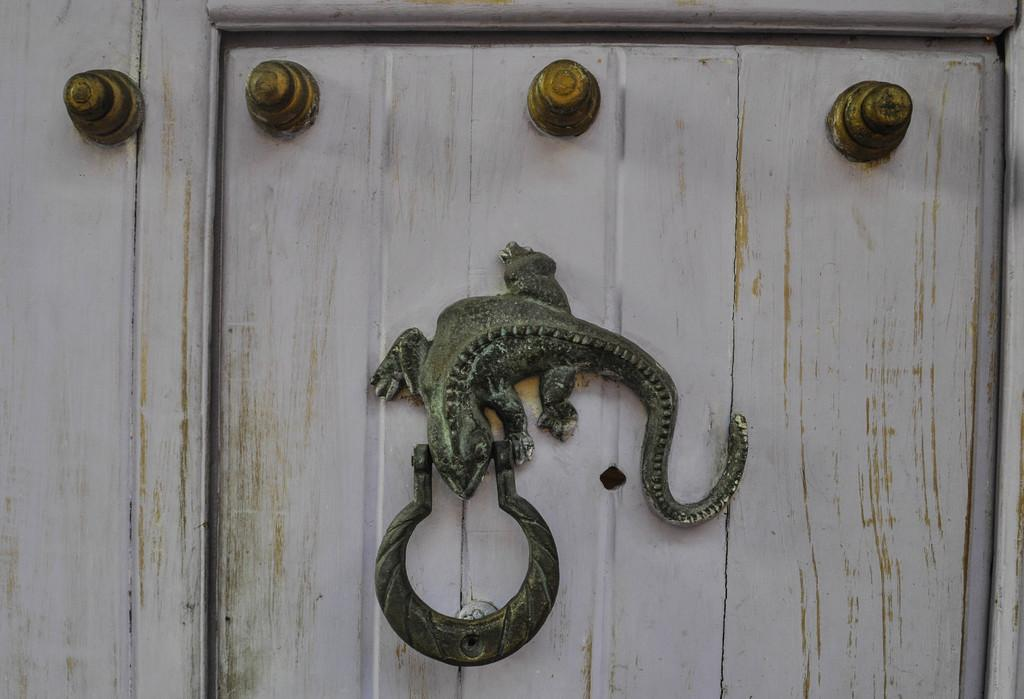What type of door is visible in the image? There is a wooden door in the image. What security features are present on the wooden door? The wooden door has bolts. What is used to hold the wooden door in place? The wooden door has a holder. What additional decorative element can be seen in the image? There is an animal sculpture in the image. What type of sheet is covering the animal sculpture in the image? There is no sheet covering the animal sculpture in the image; it is visible and not obstructed. 